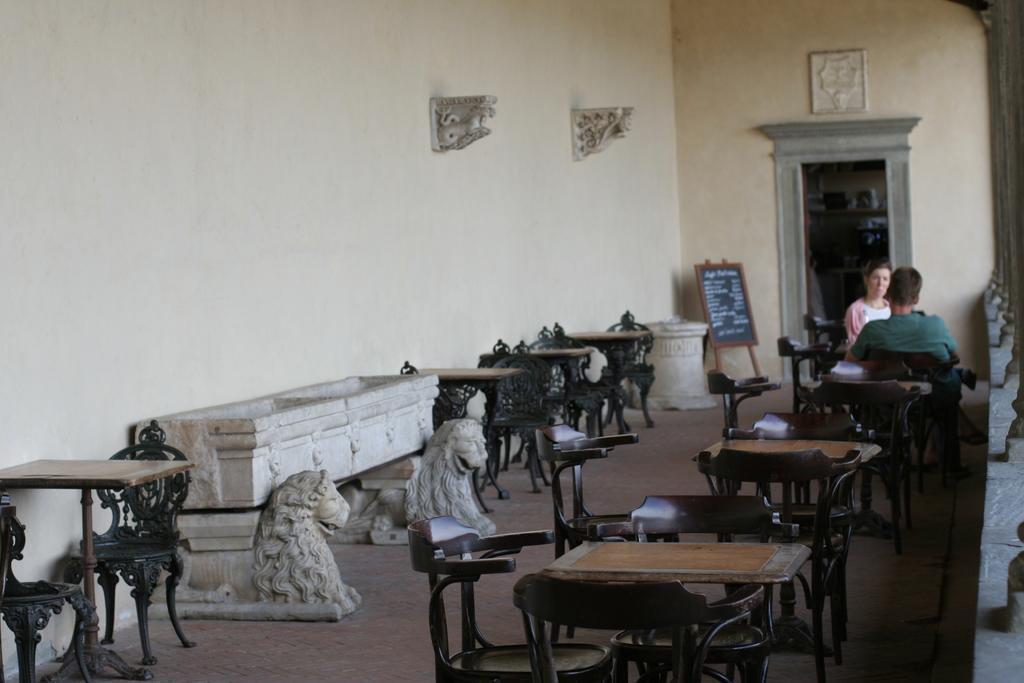Describe this image in one or two sentences. In this picture there is a man who is wearing t-shirt, trouser and shoe. He is sitting on the chair, beside him there is a woman who is wearing pink jacket and white t-shirt. She is sitting near to the door. Behind her there is a blackboard near to the wall. At the bottom I can see many wooden chairs and tables. In the bottom left there are two lions statue which is kept near to the wall. 